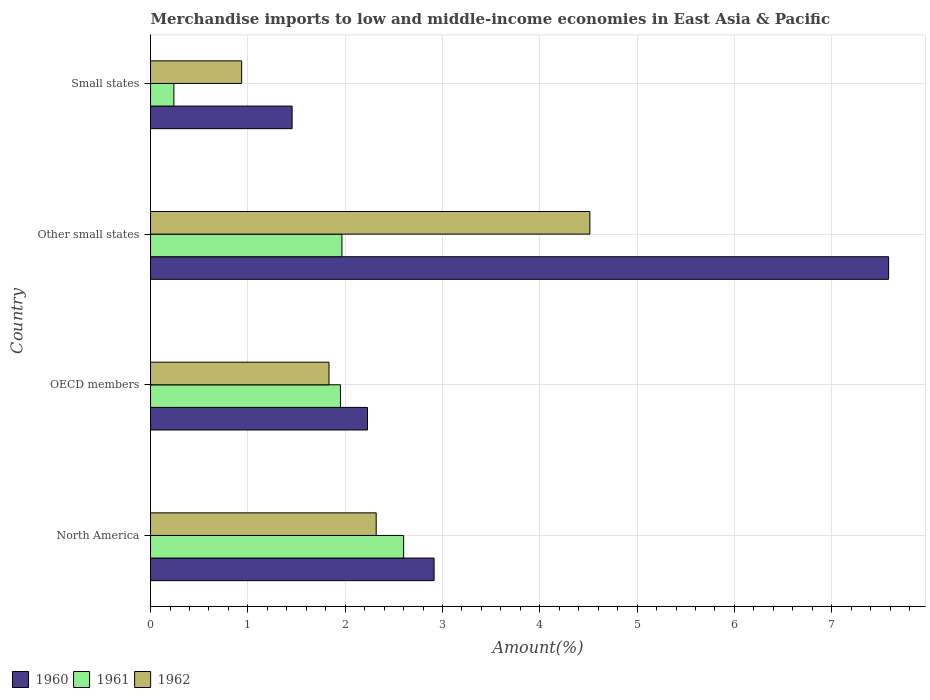How many bars are there on the 3rd tick from the bottom?
Make the answer very short. 3. What is the label of the 4th group of bars from the top?
Your answer should be very brief. North America. In how many cases, is the number of bars for a given country not equal to the number of legend labels?
Make the answer very short. 0. What is the percentage of amount earned from merchandise imports in 1962 in Small states?
Keep it short and to the point. 0.94. Across all countries, what is the maximum percentage of amount earned from merchandise imports in 1962?
Provide a succinct answer. 4.51. Across all countries, what is the minimum percentage of amount earned from merchandise imports in 1961?
Provide a succinct answer. 0.24. In which country was the percentage of amount earned from merchandise imports in 1960 maximum?
Offer a terse response. Other small states. In which country was the percentage of amount earned from merchandise imports in 1961 minimum?
Give a very brief answer. Small states. What is the total percentage of amount earned from merchandise imports in 1962 in the graph?
Give a very brief answer. 9.6. What is the difference between the percentage of amount earned from merchandise imports in 1962 in OECD members and that in Small states?
Keep it short and to the point. 0.9. What is the difference between the percentage of amount earned from merchandise imports in 1962 in Small states and the percentage of amount earned from merchandise imports in 1960 in OECD members?
Your answer should be very brief. -1.29. What is the average percentage of amount earned from merchandise imports in 1962 per country?
Make the answer very short. 2.4. What is the difference between the percentage of amount earned from merchandise imports in 1962 and percentage of amount earned from merchandise imports in 1960 in Other small states?
Provide a short and direct response. -3.07. In how many countries, is the percentage of amount earned from merchandise imports in 1960 greater than 7.4 %?
Make the answer very short. 1. What is the ratio of the percentage of amount earned from merchandise imports in 1960 in OECD members to that in Other small states?
Keep it short and to the point. 0.29. Is the percentage of amount earned from merchandise imports in 1961 in North America less than that in OECD members?
Your answer should be compact. No. What is the difference between the highest and the second highest percentage of amount earned from merchandise imports in 1960?
Your response must be concise. 4.67. What is the difference between the highest and the lowest percentage of amount earned from merchandise imports in 1962?
Give a very brief answer. 3.58. Is the sum of the percentage of amount earned from merchandise imports in 1960 in OECD members and Other small states greater than the maximum percentage of amount earned from merchandise imports in 1961 across all countries?
Your answer should be compact. Yes. What does the 1st bar from the top in North America represents?
Offer a terse response. 1962. Is it the case that in every country, the sum of the percentage of amount earned from merchandise imports in 1960 and percentage of amount earned from merchandise imports in 1962 is greater than the percentage of amount earned from merchandise imports in 1961?
Provide a succinct answer. Yes. How many bars are there?
Offer a very short reply. 12. Are all the bars in the graph horizontal?
Your answer should be very brief. Yes. Are the values on the major ticks of X-axis written in scientific E-notation?
Provide a short and direct response. No. Does the graph contain any zero values?
Provide a succinct answer. No. What is the title of the graph?
Provide a short and direct response. Merchandise imports to low and middle-income economies in East Asia & Pacific. What is the label or title of the X-axis?
Offer a terse response. Amount(%). What is the label or title of the Y-axis?
Your response must be concise. Country. What is the Amount(%) of 1960 in North America?
Ensure brevity in your answer.  2.91. What is the Amount(%) of 1961 in North America?
Your response must be concise. 2.6. What is the Amount(%) in 1962 in North America?
Your response must be concise. 2.32. What is the Amount(%) of 1960 in OECD members?
Offer a very short reply. 2.23. What is the Amount(%) in 1961 in OECD members?
Your answer should be compact. 1.95. What is the Amount(%) in 1962 in OECD members?
Offer a very short reply. 1.83. What is the Amount(%) in 1960 in Other small states?
Keep it short and to the point. 7.58. What is the Amount(%) in 1961 in Other small states?
Provide a short and direct response. 1.97. What is the Amount(%) of 1962 in Other small states?
Make the answer very short. 4.51. What is the Amount(%) in 1960 in Small states?
Your answer should be very brief. 1.45. What is the Amount(%) in 1961 in Small states?
Keep it short and to the point. 0.24. What is the Amount(%) in 1962 in Small states?
Keep it short and to the point. 0.94. Across all countries, what is the maximum Amount(%) in 1960?
Ensure brevity in your answer.  7.58. Across all countries, what is the maximum Amount(%) in 1961?
Keep it short and to the point. 2.6. Across all countries, what is the maximum Amount(%) in 1962?
Ensure brevity in your answer.  4.51. Across all countries, what is the minimum Amount(%) in 1960?
Your answer should be very brief. 1.45. Across all countries, what is the minimum Amount(%) in 1961?
Make the answer very short. 0.24. Across all countries, what is the minimum Amount(%) in 1962?
Offer a very short reply. 0.94. What is the total Amount(%) of 1960 in the graph?
Your response must be concise. 14.18. What is the total Amount(%) in 1961 in the graph?
Keep it short and to the point. 6.76. What is the total Amount(%) in 1962 in the graph?
Give a very brief answer. 9.6. What is the difference between the Amount(%) in 1960 in North America and that in OECD members?
Give a very brief answer. 0.68. What is the difference between the Amount(%) of 1961 in North America and that in OECD members?
Your answer should be very brief. 0.65. What is the difference between the Amount(%) of 1962 in North America and that in OECD members?
Provide a short and direct response. 0.48. What is the difference between the Amount(%) in 1960 in North America and that in Other small states?
Your response must be concise. -4.67. What is the difference between the Amount(%) of 1961 in North America and that in Other small states?
Offer a very short reply. 0.63. What is the difference between the Amount(%) of 1962 in North America and that in Other small states?
Your answer should be compact. -2.2. What is the difference between the Amount(%) in 1960 in North America and that in Small states?
Give a very brief answer. 1.46. What is the difference between the Amount(%) in 1961 in North America and that in Small states?
Ensure brevity in your answer.  2.36. What is the difference between the Amount(%) of 1962 in North America and that in Small states?
Ensure brevity in your answer.  1.38. What is the difference between the Amount(%) of 1960 in OECD members and that in Other small states?
Keep it short and to the point. -5.36. What is the difference between the Amount(%) in 1961 in OECD members and that in Other small states?
Give a very brief answer. -0.01. What is the difference between the Amount(%) of 1962 in OECD members and that in Other small states?
Provide a short and direct response. -2.68. What is the difference between the Amount(%) of 1960 in OECD members and that in Small states?
Give a very brief answer. 0.77. What is the difference between the Amount(%) in 1961 in OECD members and that in Small states?
Ensure brevity in your answer.  1.71. What is the difference between the Amount(%) of 1962 in OECD members and that in Small states?
Provide a succinct answer. 0.9. What is the difference between the Amount(%) of 1960 in Other small states and that in Small states?
Provide a short and direct response. 6.13. What is the difference between the Amount(%) in 1961 in Other small states and that in Small states?
Your answer should be very brief. 1.73. What is the difference between the Amount(%) of 1962 in Other small states and that in Small states?
Your response must be concise. 3.58. What is the difference between the Amount(%) of 1960 in North America and the Amount(%) of 1961 in OECD members?
Provide a succinct answer. 0.96. What is the difference between the Amount(%) in 1961 in North America and the Amount(%) in 1962 in OECD members?
Make the answer very short. 0.77. What is the difference between the Amount(%) of 1960 in North America and the Amount(%) of 1961 in Other small states?
Make the answer very short. 0.95. What is the difference between the Amount(%) of 1960 in North America and the Amount(%) of 1962 in Other small states?
Keep it short and to the point. -1.6. What is the difference between the Amount(%) in 1961 in North America and the Amount(%) in 1962 in Other small states?
Your answer should be compact. -1.91. What is the difference between the Amount(%) of 1960 in North America and the Amount(%) of 1961 in Small states?
Offer a terse response. 2.67. What is the difference between the Amount(%) in 1960 in North America and the Amount(%) in 1962 in Small states?
Offer a terse response. 1.98. What is the difference between the Amount(%) in 1961 in North America and the Amount(%) in 1962 in Small states?
Provide a short and direct response. 1.66. What is the difference between the Amount(%) of 1960 in OECD members and the Amount(%) of 1961 in Other small states?
Provide a succinct answer. 0.26. What is the difference between the Amount(%) in 1960 in OECD members and the Amount(%) in 1962 in Other small states?
Ensure brevity in your answer.  -2.29. What is the difference between the Amount(%) in 1961 in OECD members and the Amount(%) in 1962 in Other small states?
Your answer should be compact. -2.56. What is the difference between the Amount(%) of 1960 in OECD members and the Amount(%) of 1961 in Small states?
Ensure brevity in your answer.  1.99. What is the difference between the Amount(%) of 1960 in OECD members and the Amount(%) of 1962 in Small states?
Ensure brevity in your answer.  1.29. What is the difference between the Amount(%) of 1961 in OECD members and the Amount(%) of 1962 in Small states?
Give a very brief answer. 1.02. What is the difference between the Amount(%) in 1960 in Other small states and the Amount(%) in 1961 in Small states?
Give a very brief answer. 7.34. What is the difference between the Amount(%) in 1960 in Other small states and the Amount(%) in 1962 in Small states?
Provide a short and direct response. 6.65. What is the difference between the Amount(%) in 1961 in Other small states and the Amount(%) in 1962 in Small states?
Your answer should be compact. 1.03. What is the average Amount(%) of 1960 per country?
Offer a terse response. 3.55. What is the average Amount(%) in 1961 per country?
Make the answer very short. 1.69. What is the average Amount(%) of 1962 per country?
Your response must be concise. 2.4. What is the difference between the Amount(%) of 1960 and Amount(%) of 1961 in North America?
Your answer should be very brief. 0.31. What is the difference between the Amount(%) of 1960 and Amount(%) of 1962 in North America?
Your answer should be very brief. 0.6. What is the difference between the Amount(%) in 1961 and Amount(%) in 1962 in North America?
Your answer should be compact. 0.28. What is the difference between the Amount(%) in 1960 and Amount(%) in 1961 in OECD members?
Your answer should be very brief. 0.28. What is the difference between the Amount(%) in 1960 and Amount(%) in 1962 in OECD members?
Provide a succinct answer. 0.4. What is the difference between the Amount(%) of 1961 and Amount(%) of 1962 in OECD members?
Your response must be concise. 0.12. What is the difference between the Amount(%) of 1960 and Amount(%) of 1961 in Other small states?
Provide a succinct answer. 5.62. What is the difference between the Amount(%) of 1960 and Amount(%) of 1962 in Other small states?
Provide a succinct answer. 3.07. What is the difference between the Amount(%) in 1961 and Amount(%) in 1962 in Other small states?
Your answer should be compact. -2.55. What is the difference between the Amount(%) of 1960 and Amount(%) of 1961 in Small states?
Make the answer very short. 1.22. What is the difference between the Amount(%) in 1960 and Amount(%) in 1962 in Small states?
Offer a terse response. 0.52. What is the difference between the Amount(%) in 1961 and Amount(%) in 1962 in Small states?
Give a very brief answer. -0.7. What is the ratio of the Amount(%) in 1960 in North America to that in OECD members?
Provide a short and direct response. 1.31. What is the ratio of the Amount(%) in 1961 in North America to that in OECD members?
Keep it short and to the point. 1.33. What is the ratio of the Amount(%) of 1962 in North America to that in OECD members?
Keep it short and to the point. 1.26. What is the ratio of the Amount(%) in 1960 in North America to that in Other small states?
Keep it short and to the point. 0.38. What is the ratio of the Amount(%) of 1961 in North America to that in Other small states?
Offer a terse response. 1.32. What is the ratio of the Amount(%) in 1962 in North America to that in Other small states?
Offer a terse response. 0.51. What is the ratio of the Amount(%) in 1960 in North America to that in Small states?
Provide a short and direct response. 2. What is the ratio of the Amount(%) of 1961 in North America to that in Small states?
Keep it short and to the point. 10.84. What is the ratio of the Amount(%) of 1962 in North America to that in Small states?
Your answer should be compact. 2.48. What is the ratio of the Amount(%) in 1960 in OECD members to that in Other small states?
Offer a very short reply. 0.29. What is the ratio of the Amount(%) of 1962 in OECD members to that in Other small states?
Make the answer very short. 0.41. What is the ratio of the Amount(%) in 1960 in OECD members to that in Small states?
Ensure brevity in your answer.  1.53. What is the ratio of the Amount(%) in 1961 in OECD members to that in Small states?
Your answer should be very brief. 8.14. What is the ratio of the Amount(%) of 1962 in OECD members to that in Small states?
Provide a short and direct response. 1.96. What is the ratio of the Amount(%) in 1960 in Other small states to that in Small states?
Give a very brief answer. 5.21. What is the ratio of the Amount(%) of 1961 in Other small states to that in Small states?
Your answer should be compact. 8.2. What is the ratio of the Amount(%) of 1962 in Other small states to that in Small states?
Provide a succinct answer. 4.82. What is the difference between the highest and the second highest Amount(%) in 1960?
Provide a succinct answer. 4.67. What is the difference between the highest and the second highest Amount(%) of 1961?
Ensure brevity in your answer.  0.63. What is the difference between the highest and the second highest Amount(%) of 1962?
Provide a short and direct response. 2.2. What is the difference between the highest and the lowest Amount(%) of 1960?
Your response must be concise. 6.13. What is the difference between the highest and the lowest Amount(%) in 1961?
Provide a succinct answer. 2.36. What is the difference between the highest and the lowest Amount(%) in 1962?
Make the answer very short. 3.58. 